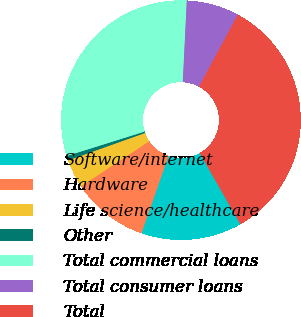Convert chart. <chart><loc_0><loc_0><loc_500><loc_500><pie_chart><fcel>Software/internet<fcel>Hardware<fcel>Life science/healthcare<fcel>Other<fcel>Total commercial loans<fcel>Total consumer loans<fcel>Total<nl><fcel>13.6%<fcel>10.35%<fcel>3.85%<fcel>0.61%<fcel>30.62%<fcel>7.1%<fcel>33.87%<nl></chart> 